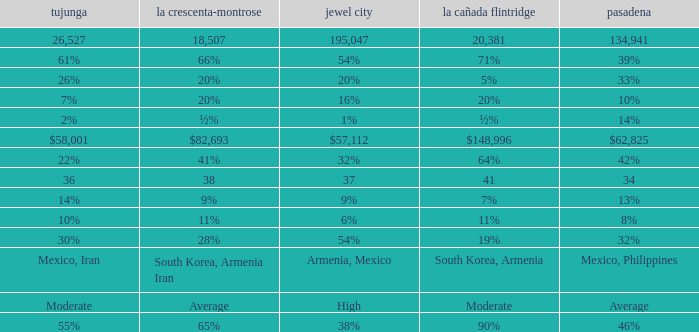What is the figure for Pasadena when Tujunga is 36? 34.0. 